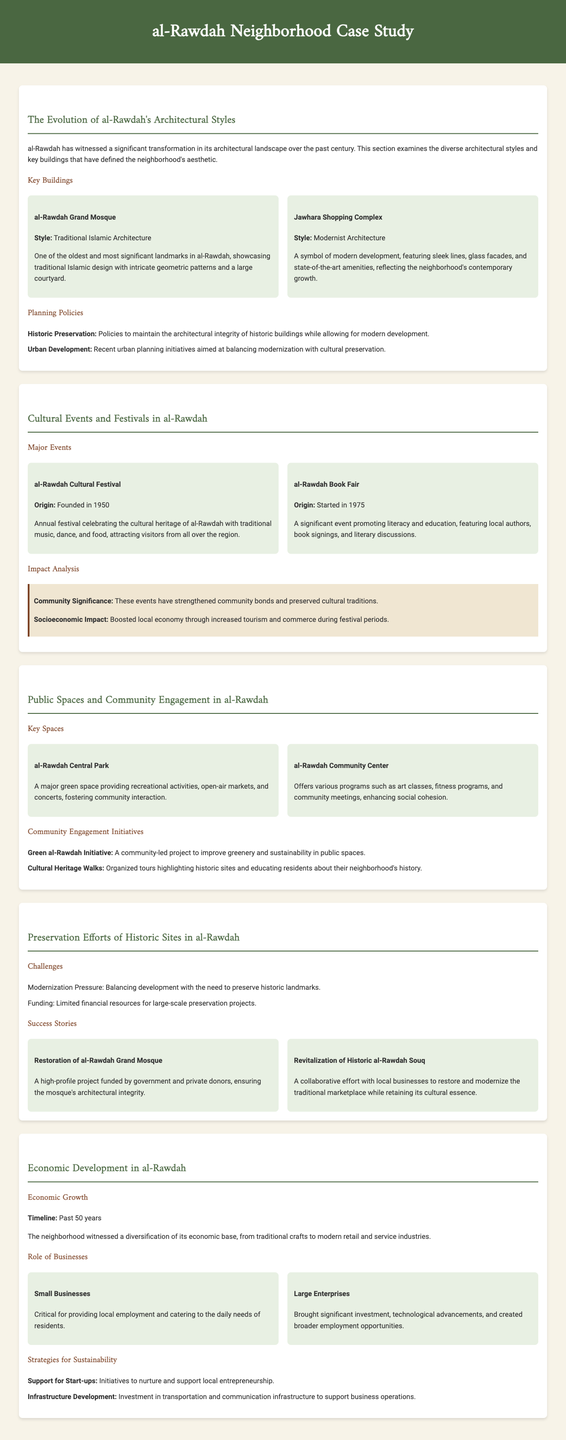What is one of the key architectural styles seen in al-Rawdah? The key architectural style mentioned is Traditional Islamic Architecture, exemplified by the al-Rawdah Grand Mosque.
Answer: Traditional Islamic Architecture How many cultural events are highlighted in the document? Two major cultural events are highlighted: the al-Rawdah Cultural Festival and the al-Rawdah Book Fair.
Answer: Two When was the al-Rawdah Cultural Festival founded? The festival was founded in 1950, as stated in the cultural events section.
Answer: 1950 What is the primary focus of the Green al-Rawdah Initiative? The Green al-Rawdah Initiative focuses on improving greenery and sustainability in public spaces.
Answer: Greenery and sustainability What challenge does the preservation of historic sites face according to the document? One major challenge mentioned is Modernization Pressure.
Answer: Modernization Pressure What significant success story is related to the al-Rawdah Grand Mosque? The restoration of the al-Rawdah Grand Mosque is highlighted as a success story in preservation efforts.
Answer: Restoration of the al-Rawdah Grand Mosque Which large enterprise role is mentioned for economic development? Large enterprises are mentioned as having brought significant investment and employment opportunities.
Answer: Investment and employment What year did the al-Rawdah Book Fair start? The al-Rawdah Book Fair started in 1975, as indicated in the events section.
Answer: 1975 